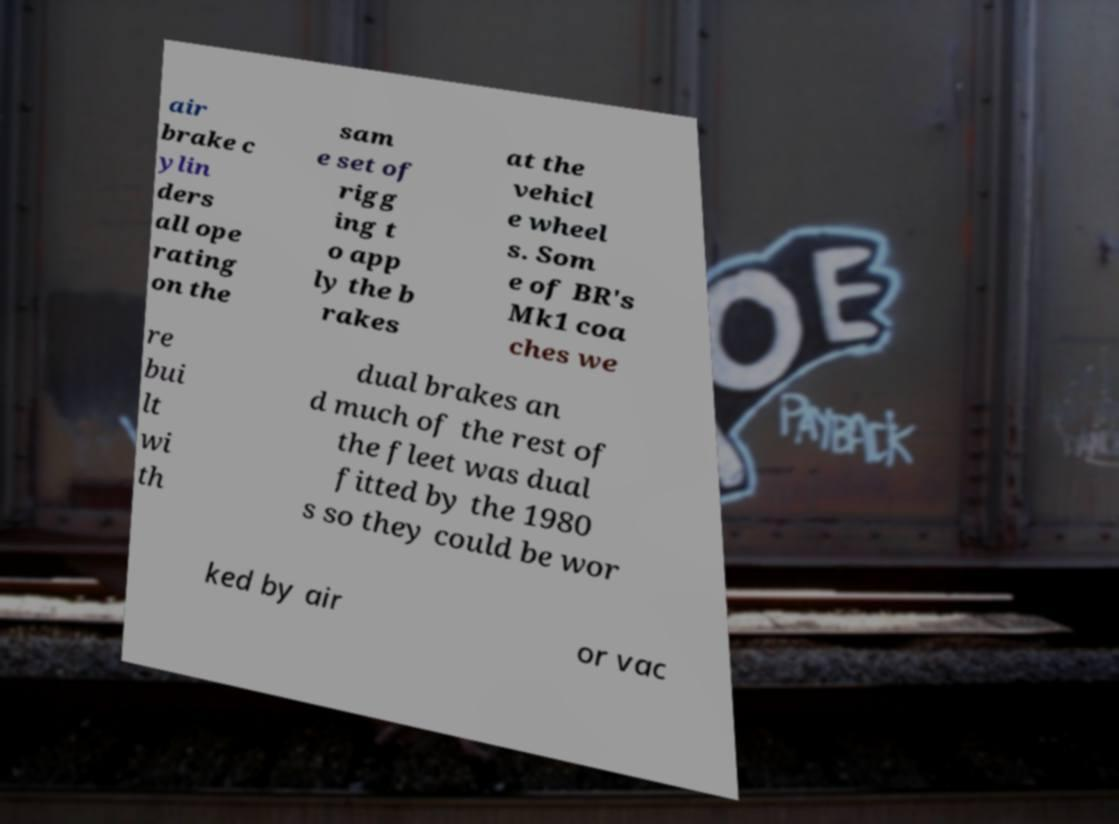What messages or text are displayed in this image? I need them in a readable, typed format. air brake c ylin ders all ope rating on the sam e set of rigg ing t o app ly the b rakes at the vehicl e wheel s. Som e of BR's Mk1 coa ches we re bui lt wi th dual brakes an d much of the rest of the fleet was dual fitted by the 1980 s so they could be wor ked by air or vac 